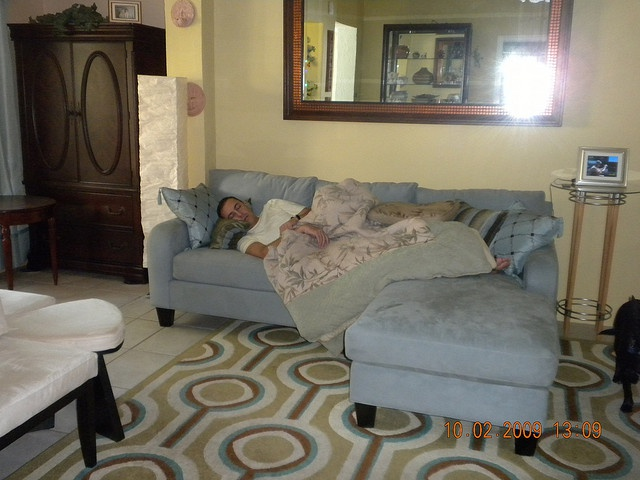Describe the objects in this image and their specific colors. I can see couch in gray tones, bed in gray, darkgray, and black tones, people in gray, darkgray, and maroon tones, and tv in gray, darkgray, darkblue, and black tones in this image. 